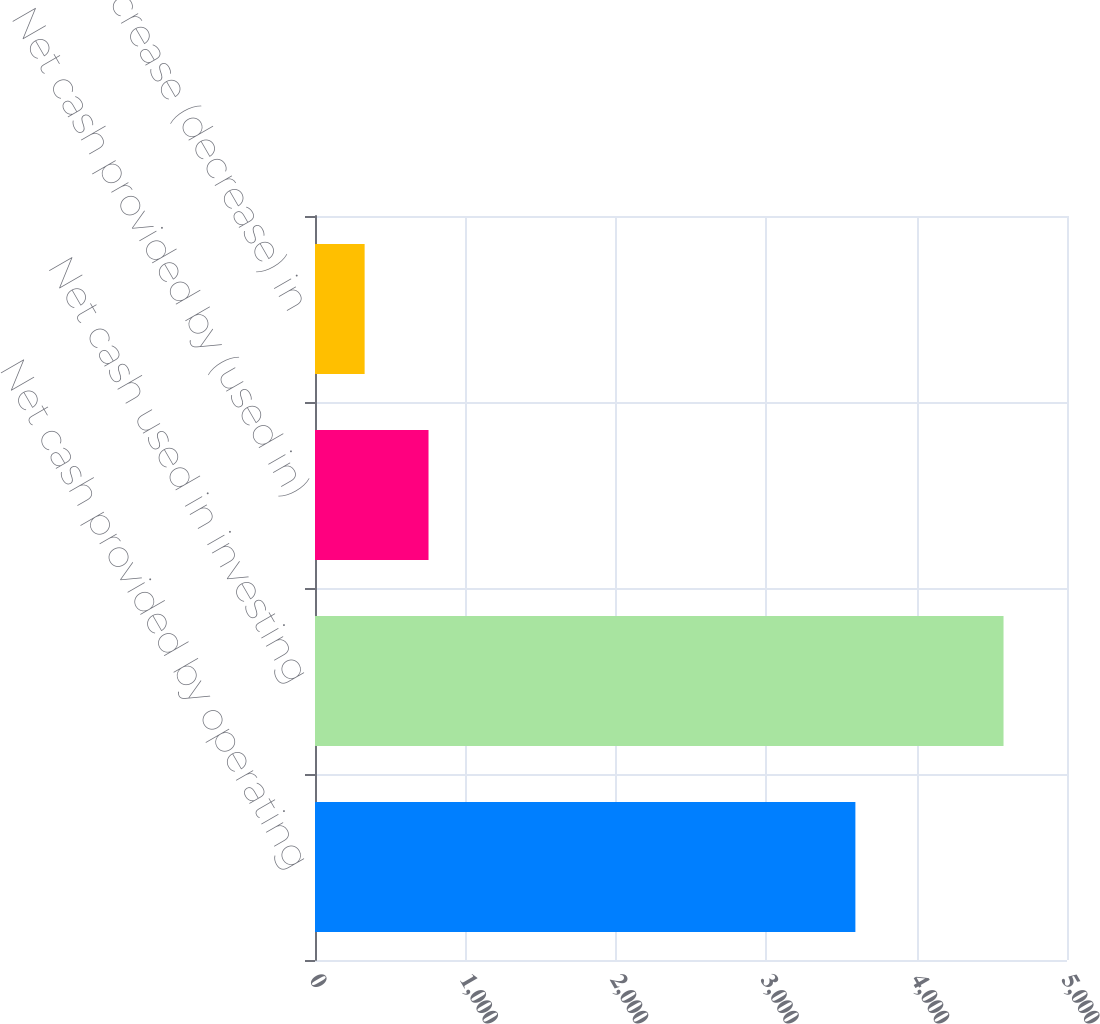Convert chart to OTSL. <chart><loc_0><loc_0><loc_500><loc_500><bar_chart><fcel>Net cash provided by operating<fcel>Net cash used in investing<fcel>Net cash provided by (used in)<fcel>Net increase (decrease) in<nl><fcel>3593<fcel>4578<fcel>754.8<fcel>330<nl></chart> 